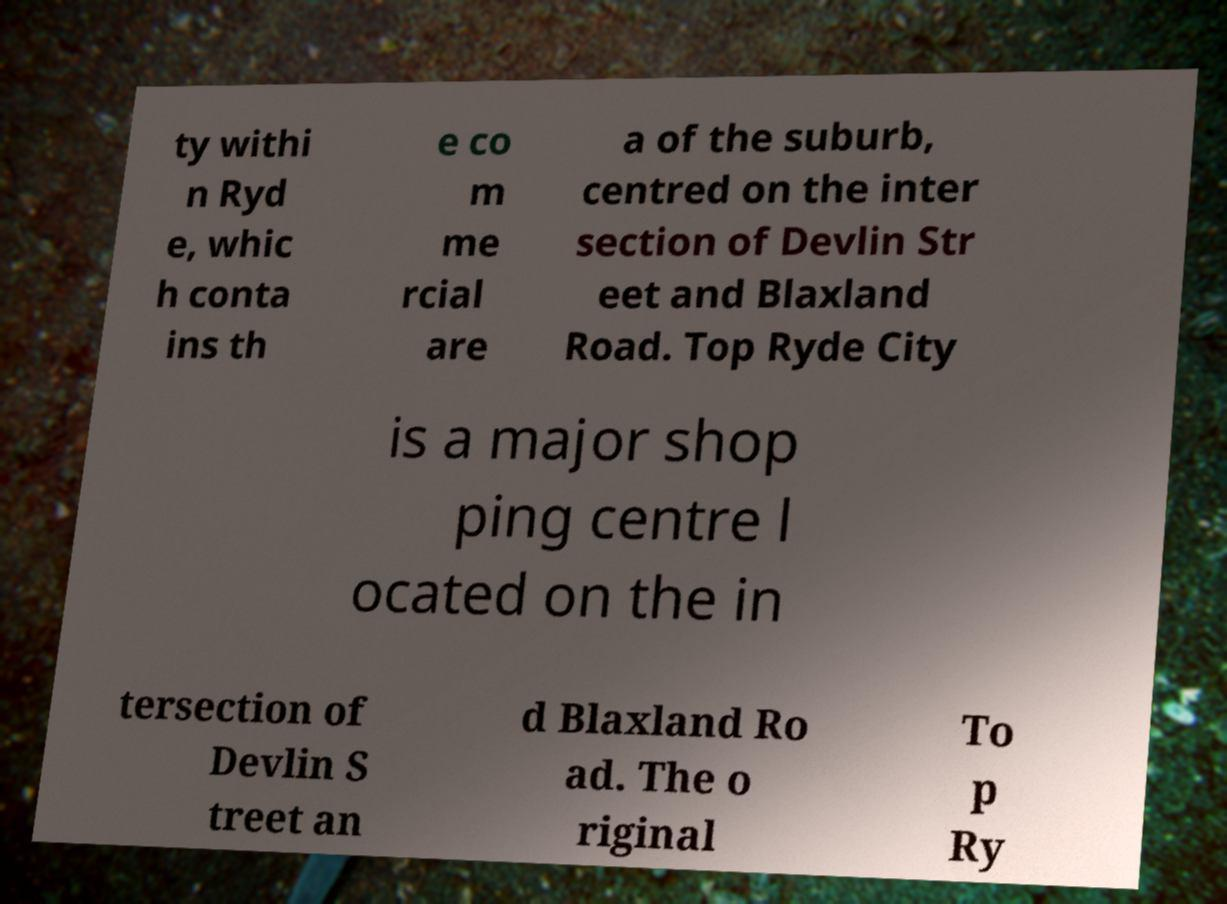For documentation purposes, I need the text within this image transcribed. Could you provide that? ty withi n Ryd e, whic h conta ins th e co m me rcial are a of the suburb, centred on the inter section of Devlin Str eet and Blaxland Road. Top Ryde City is a major shop ping centre l ocated on the in tersection of Devlin S treet an d Blaxland Ro ad. The o riginal To p Ry 